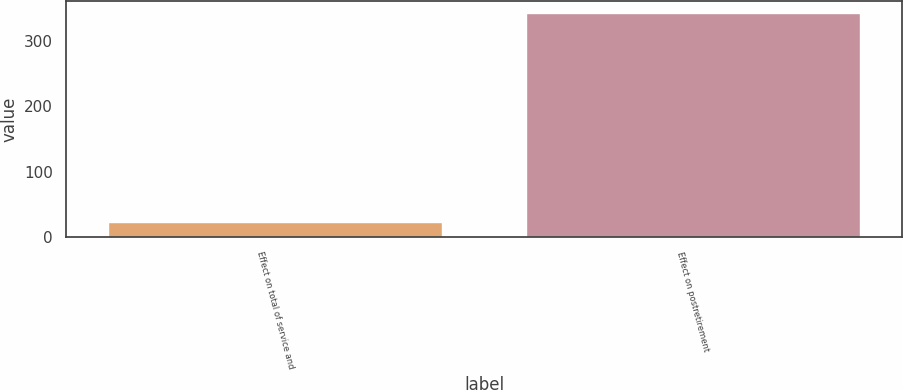Convert chart to OTSL. <chart><loc_0><loc_0><loc_500><loc_500><bar_chart><fcel>Effect on total of service and<fcel>Effect on postretirement<nl><fcel>23<fcel>343<nl></chart> 